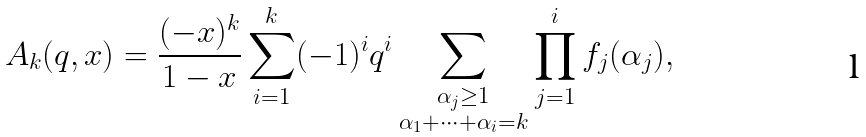Convert formula to latex. <formula><loc_0><loc_0><loc_500><loc_500>A _ { k } ( q , x ) = \frac { ( - x ) ^ { k } } { 1 - x } \sum _ { i = 1 } ^ { k } ( - 1 ) ^ { i } q ^ { i } \sum _ { \substack { \alpha _ { j } \geq 1 \\ \alpha _ { 1 } + \dots + \alpha _ { i } = k } } \prod _ { j = 1 } ^ { i } f _ { j } ( \alpha _ { j } ) ,</formula> 